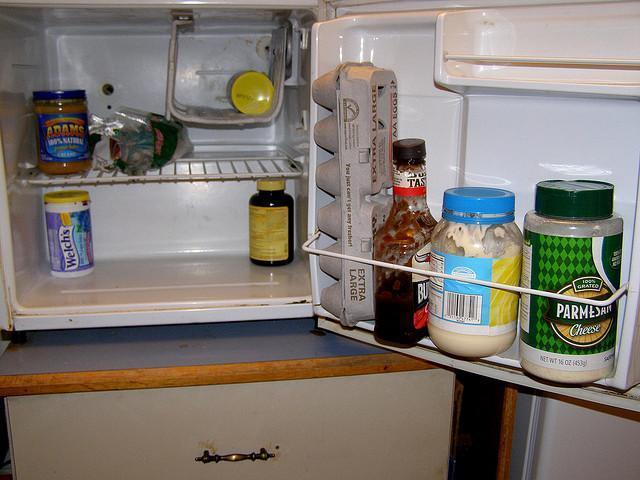How many objects here contain items from the dairy group?
Pick the right solution, then justify: 'Answer: answer
Rationale: rationale.'
Options: Four, three, one, two. Answer: three.
Rationale: There is mayonnaise, cheese and eggs. 